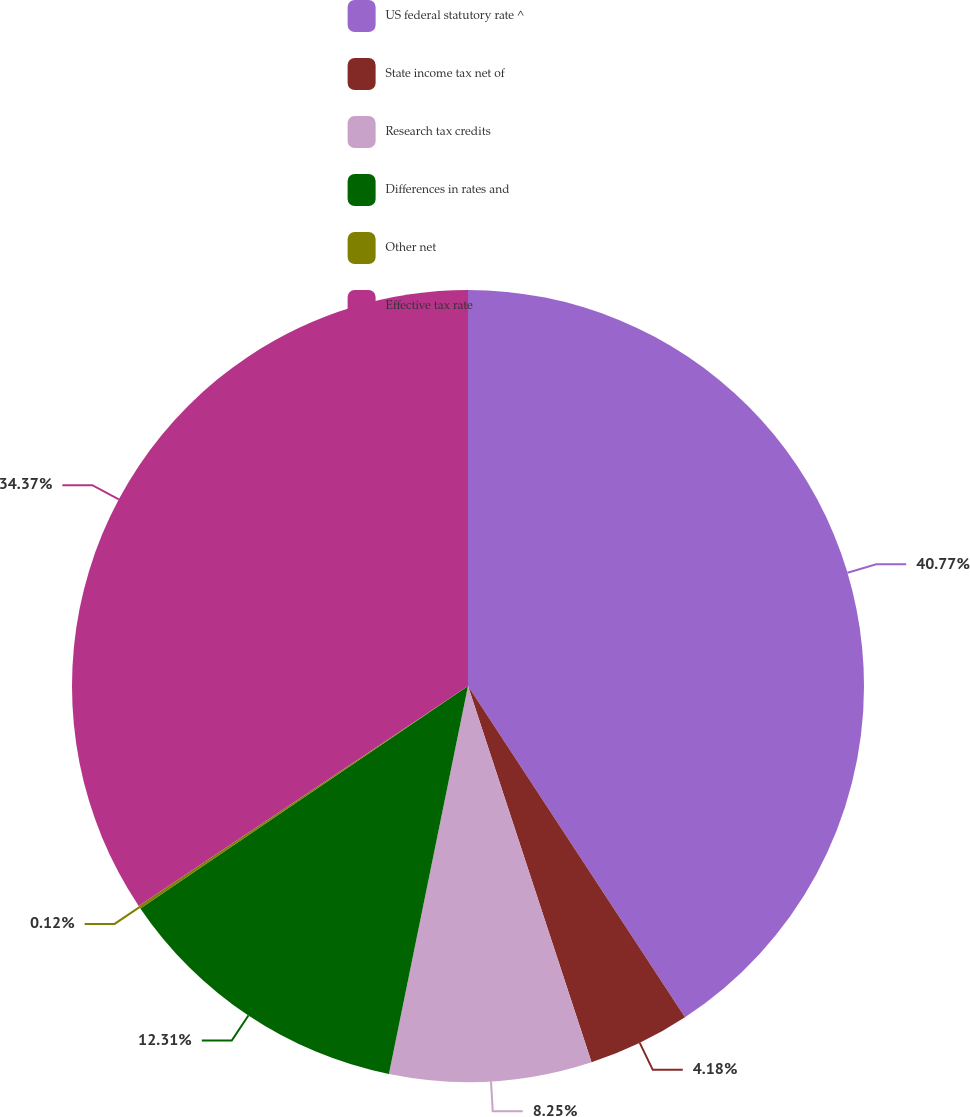Convert chart to OTSL. <chart><loc_0><loc_0><loc_500><loc_500><pie_chart><fcel>US federal statutory rate ^<fcel>State income tax net of<fcel>Research tax credits<fcel>Differences in rates and<fcel>Other net<fcel>Effective tax rate<nl><fcel>40.77%<fcel>4.18%<fcel>8.25%<fcel>12.31%<fcel>0.12%<fcel>34.37%<nl></chart> 